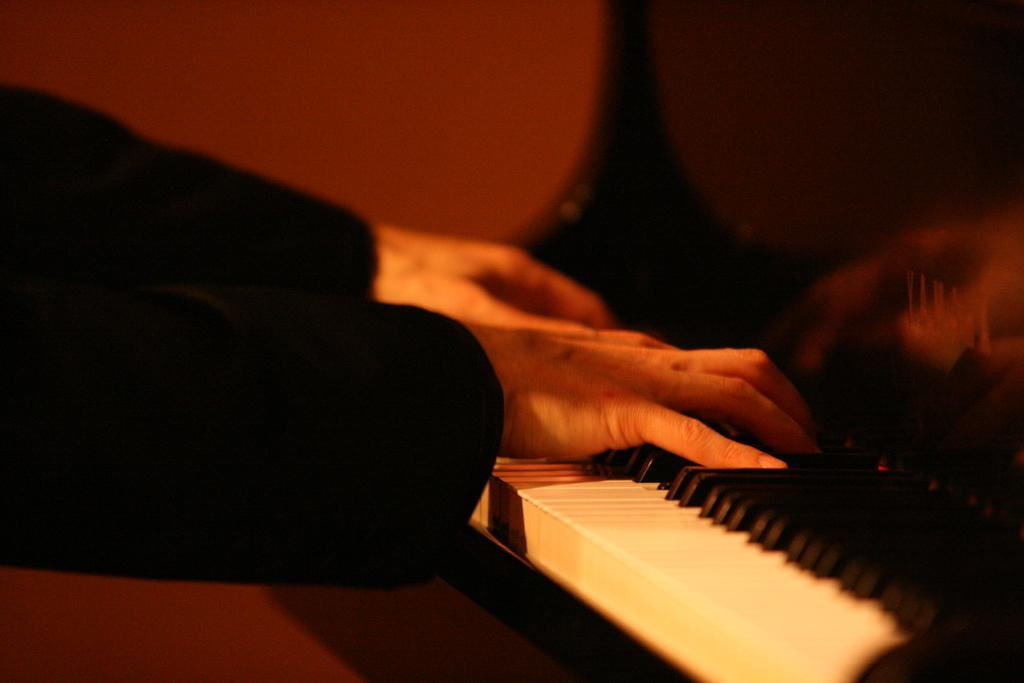What is the main subject of the image? There is a person in the image. What is the person doing in the image? The person is playing a piano keyboard. What type of appliance is the person using to cast a spell in the image? There is no appliance or spell casting present in the image; the person is simply playing a piano keyboard. 